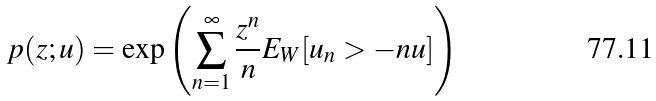<formula> <loc_0><loc_0><loc_500><loc_500>p ( z ; u ) = { \exp } \left ( \sum _ { n = 1 } ^ { \infty } \frac { z ^ { n } } { n } E _ { W } [ u _ { n } > - n u ] \right )</formula> 